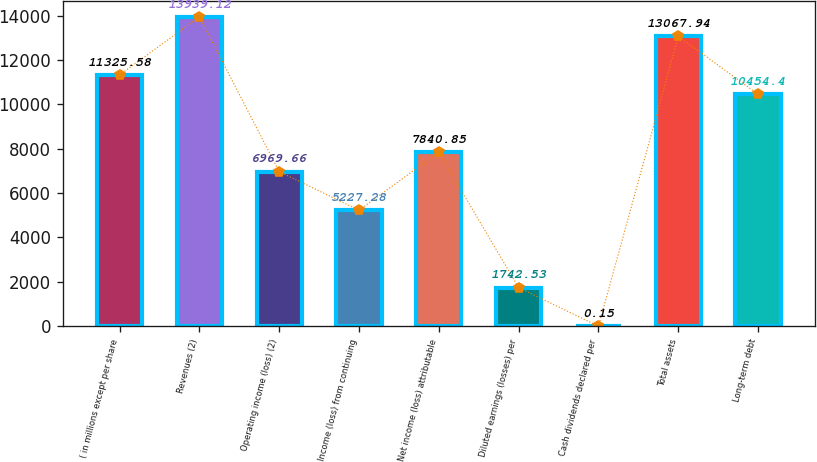Convert chart to OTSL. <chart><loc_0><loc_0><loc_500><loc_500><bar_chart><fcel>( in millions except per share<fcel>Revenues (2)<fcel>Operating income (loss) (2)<fcel>Income (loss) from continuing<fcel>Net income (loss) attributable<fcel>Diluted earnings (losses) per<fcel>Cash dividends declared per<fcel>Total assets<fcel>Long-term debt<nl><fcel>11325.6<fcel>13939.1<fcel>6969.66<fcel>5227.28<fcel>7840.85<fcel>1742.53<fcel>0.15<fcel>13067.9<fcel>10454.4<nl></chart> 